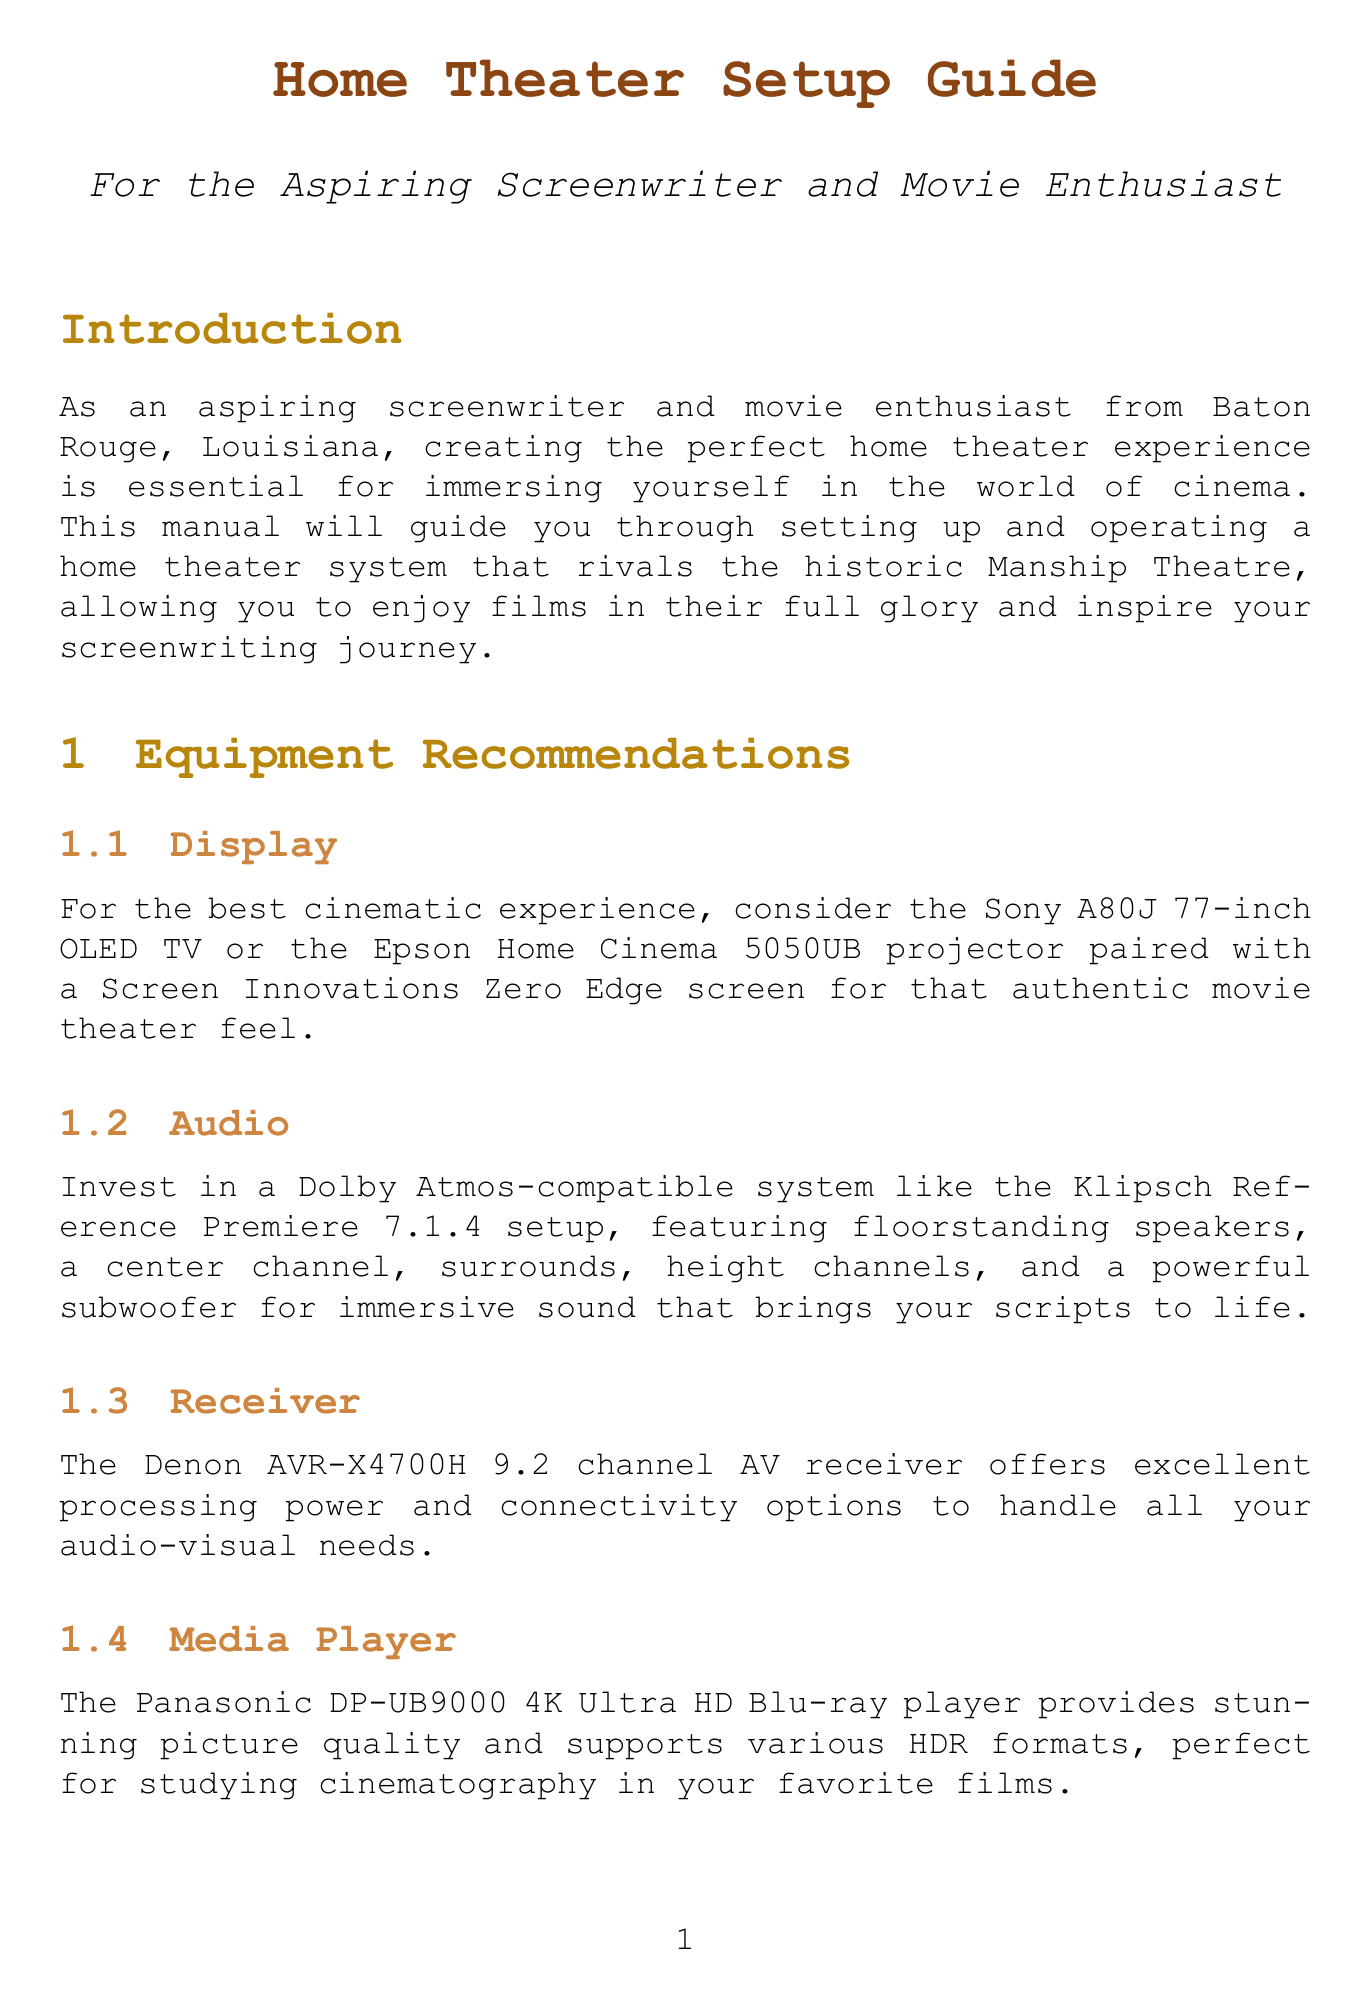What is the recommended TV model for the best cinematic experience? The document specifically suggests the Sony A80J 77-inch OLED TV as a top recommendation for display.
Answer: Sony A80J 77-inch OLED TV What is the distance to position the main viewing seat? The document states that the main viewing seat should be at a distance of 1.5 times the screen width for optimal immersion.
Answer: 1.5 times the screen width Which system is suggested for audio? The manual recommends investing in a Dolby Atmos-compatible system like the Klipsch Reference Premiere 7.1.4 setup.
Answer: Klipsch Reference Premiere 7.1.4 What acoustic elements are mentioned for sound quality? The document advises using acoustic panels from GIK Acoustics to improve sound quality and reduce echoes.
Answer: Acoustic panels from GIK Acoustics What is identified as a useful tool for video calibration? The document mentions a DIY calibration disc like the Spears & Munsil UHD HDR Benchmark as a useful tool for video calibration.
Answer: Spears & Munsil UHD HDR Benchmark Which type of seating is recommended for a cinema feel? The manual suggests considering tiered seating such as the Seatcraft Diamante home theater seats for a true cinema experience.
Answer: Seatcraft Diamante What type of curtains are recommended to control ambient light? The document recommends blackout curtains, specifically from Baton Rouge's Custom Window Treatments, to help control ambient light.
Answer: Blackout curtains What specific software should be used to optimize audio performance? The document states that Audyssey MultEQ XT32 room correction software should be utilized to optimize audio performance.
Answer: Audyssey MultEQ XT32 What yearly event can help keep up with home theater trends? The document suggests attending the annual CEDIA Expo to stay informed about the latest home theater trends.
Answer: CEDIA Expo 